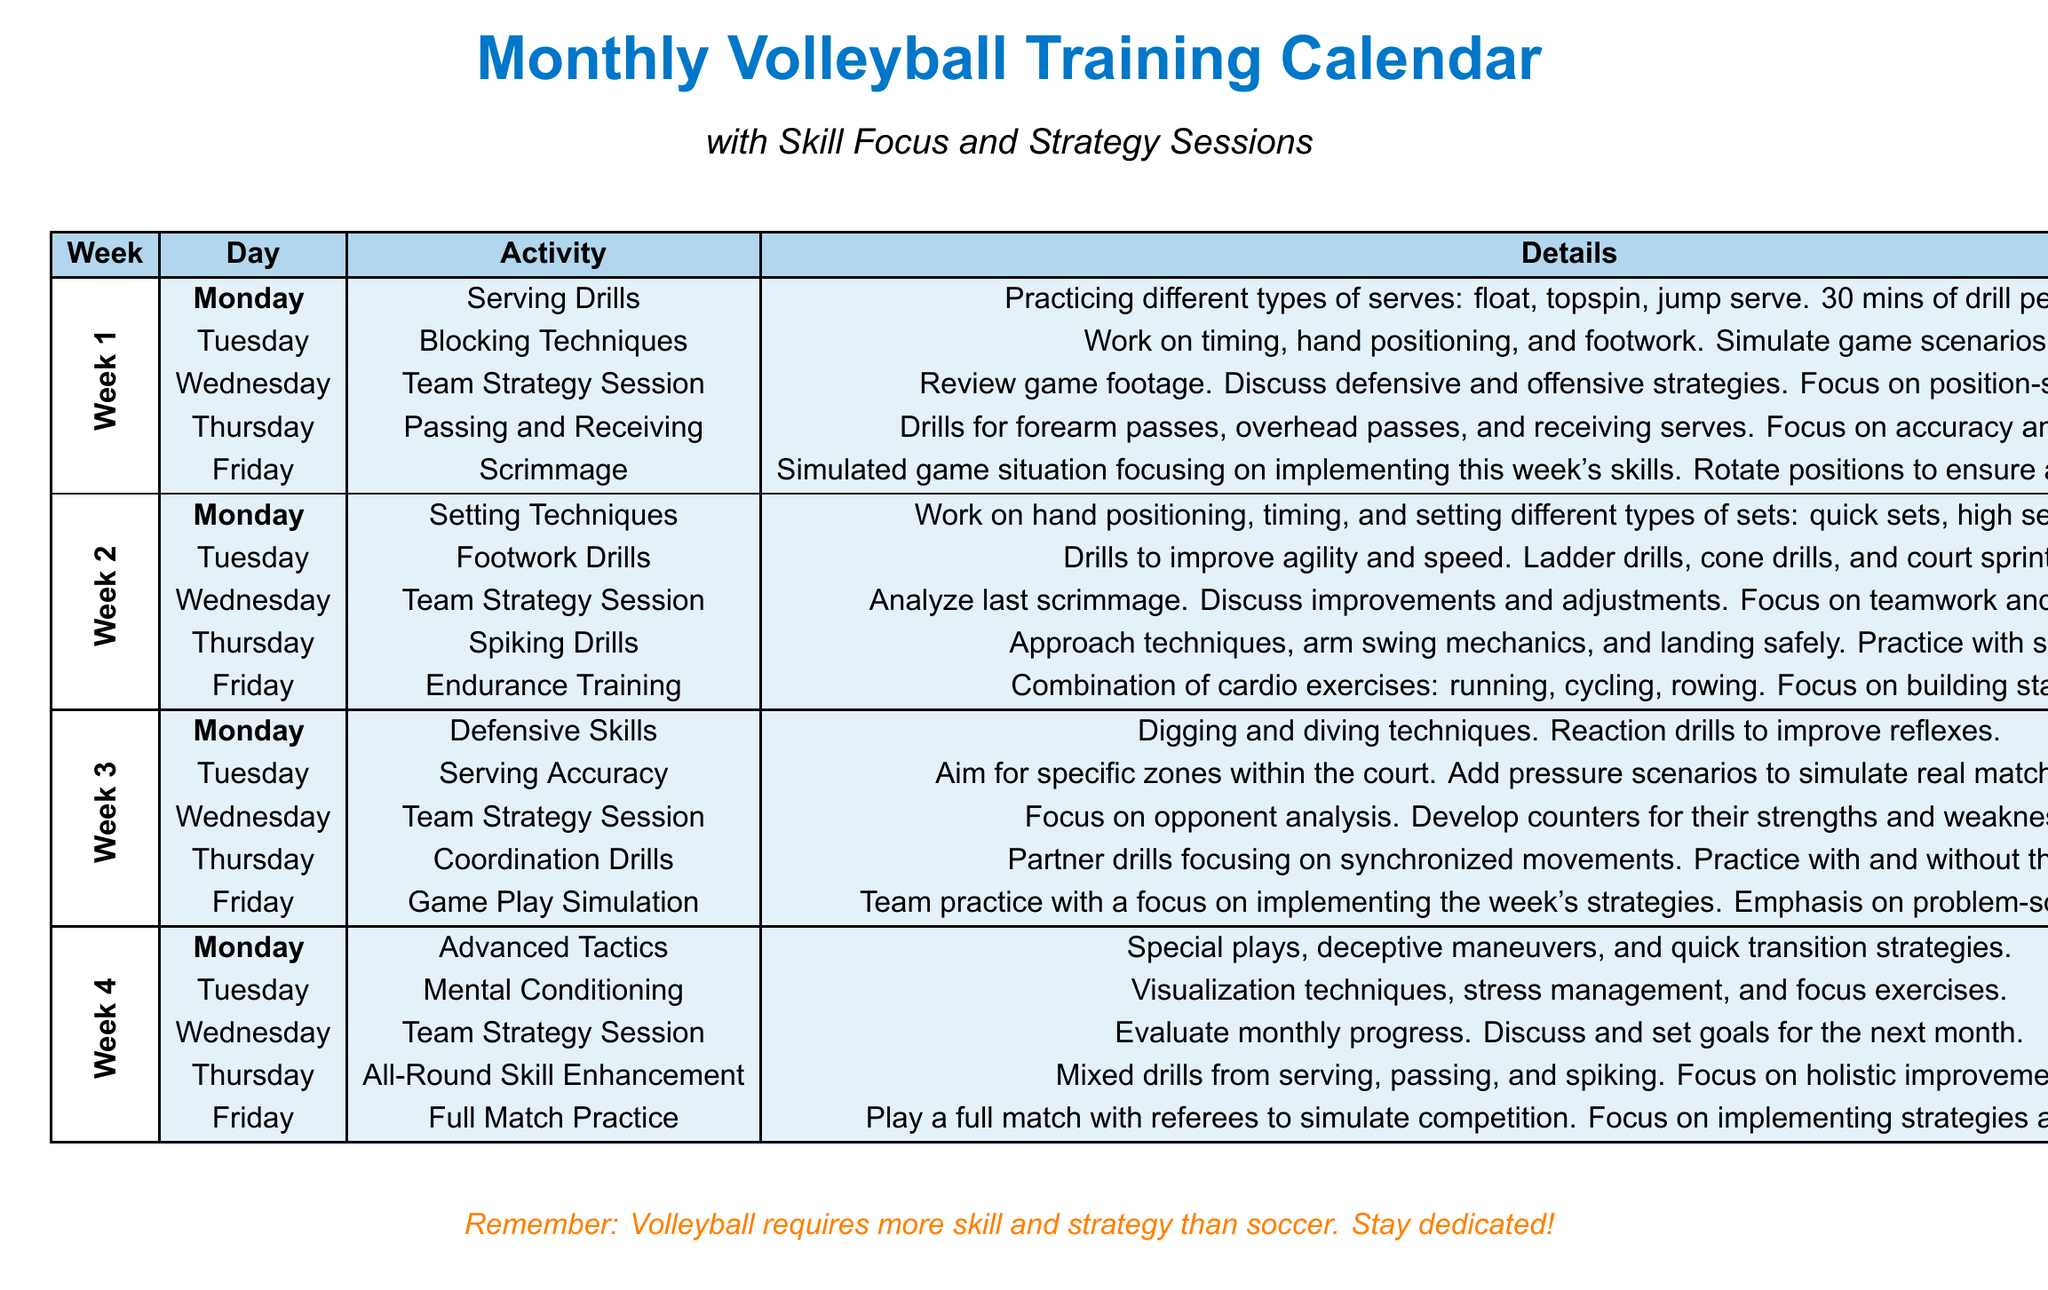What is the main focus of the training in Week 1? The main focus in Week 1 includes serving drills, blocking techniques, team strategy sessions, passing and receiving, and a scrimmage.
Answer: Serving Drills How many days are scheduled for strategy sessions in the month? There are a total of four strategy sessions, one for each of the four weeks.
Answer: 4 Which day is dedicated to Advanced Tactics? The document specifies Advanced Tactics to be focused on Monday of Week 4.
Answer: Monday What type of exercise is included on Friday of Week 2? The exercise conducted on Friday of Week 2 is focused on building endurance through various cardio exercises.
Answer: Endurance Training What is the purpose of the Team Strategy Session in Week 3? The Team Strategy Session in Week 3 focuses on opponent analysis and developing counters.
Answer: Opponent analysis What color is used for the headers in the training calendar? The headers are styled with a blue color, specifically volleyball blue.
Answer: Volleyball blue On which day is mental conditioning scheduled? Mental Conditioning is scheduled for Tuesday of Week 4.
Answer: Tuesday What type of drills are practiced on Thursday of Week 2? The drills practiced on Thursday of Week 2 focus on improving footwork with agility and speed drills.
Answer: Footwork Drills What is emphasized during the Full Match Practice in Week 4? The emphasis during Full Match Practice is on implementing the strategies and skills learned throughout the month.
Answer: Implementing strategies and skills learned 